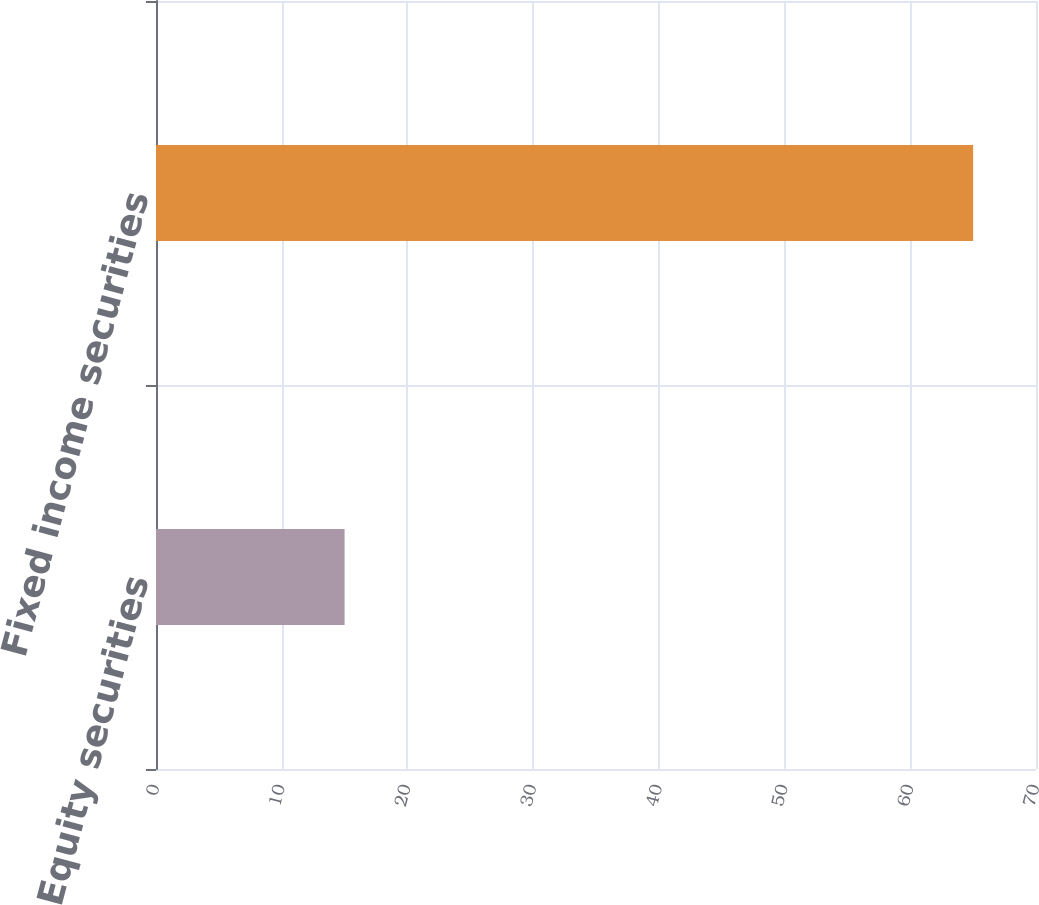<chart> <loc_0><loc_0><loc_500><loc_500><bar_chart><fcel>Equity securities<fcel>Fixed income securities<nl><fcel>15<fcel>65<nl></chart> 